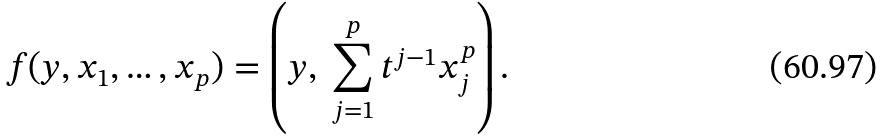Convert formula to latex. <formula><loc_0><loc_0><loc_500><loc_500>f ( y , x _ { 1 } , \dots , x _ { p } ) = \left ( y , \ \sum _ { j = 1 } ^ { p } t ^ { j - 1 } x _ { j } ^ { p } \right ) .</formula> 